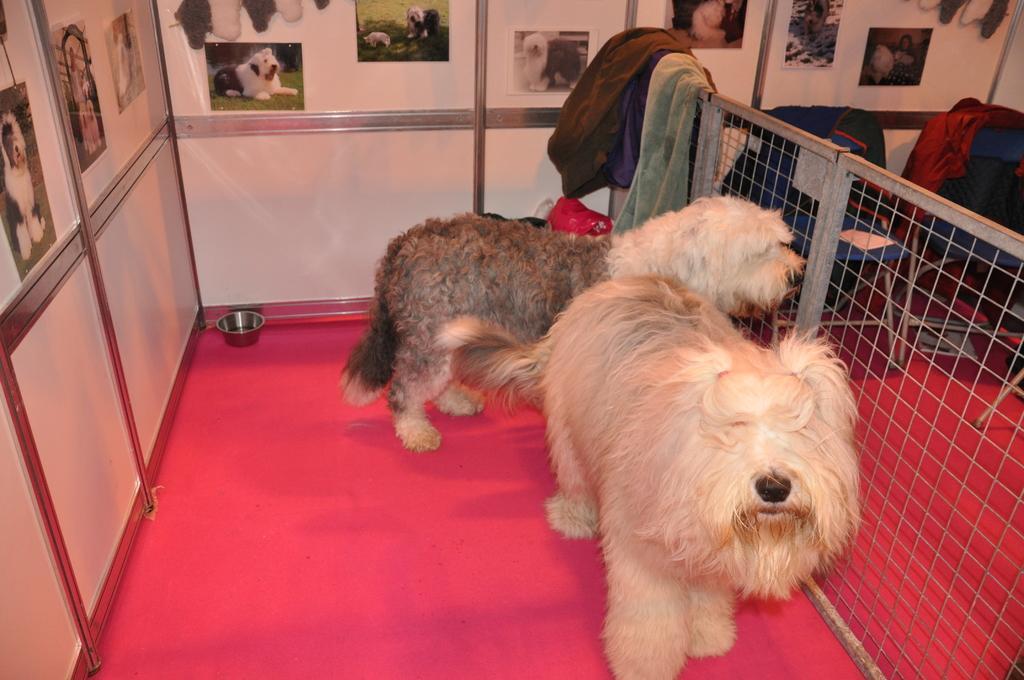In one or two sentences, can you explain what this image depicts? In the center of the image we can see two dogs, on the red carpet. And we can see, dogs are in cream and brown color. In the background there is a fence, chairs, books, clothes, collection of photos, one bowl and a few other objects. 